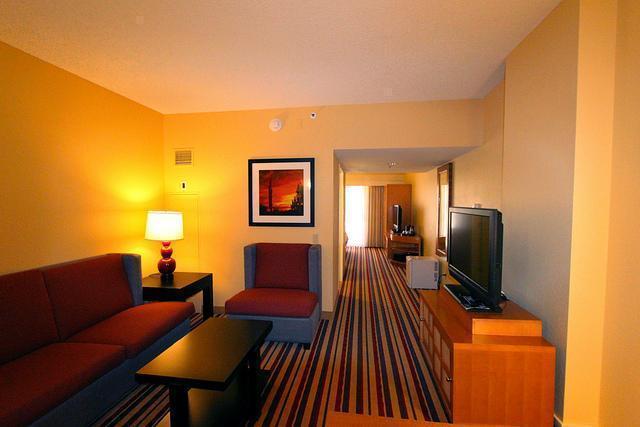What can be done with the appliance in this room?
Choose the right answer and clarify with the format: 'Answer: answer
Rationale: rationale.'
Options: Cooling, cooking, washing, viewing. Answer: viewing.
Rationale: It is a television 